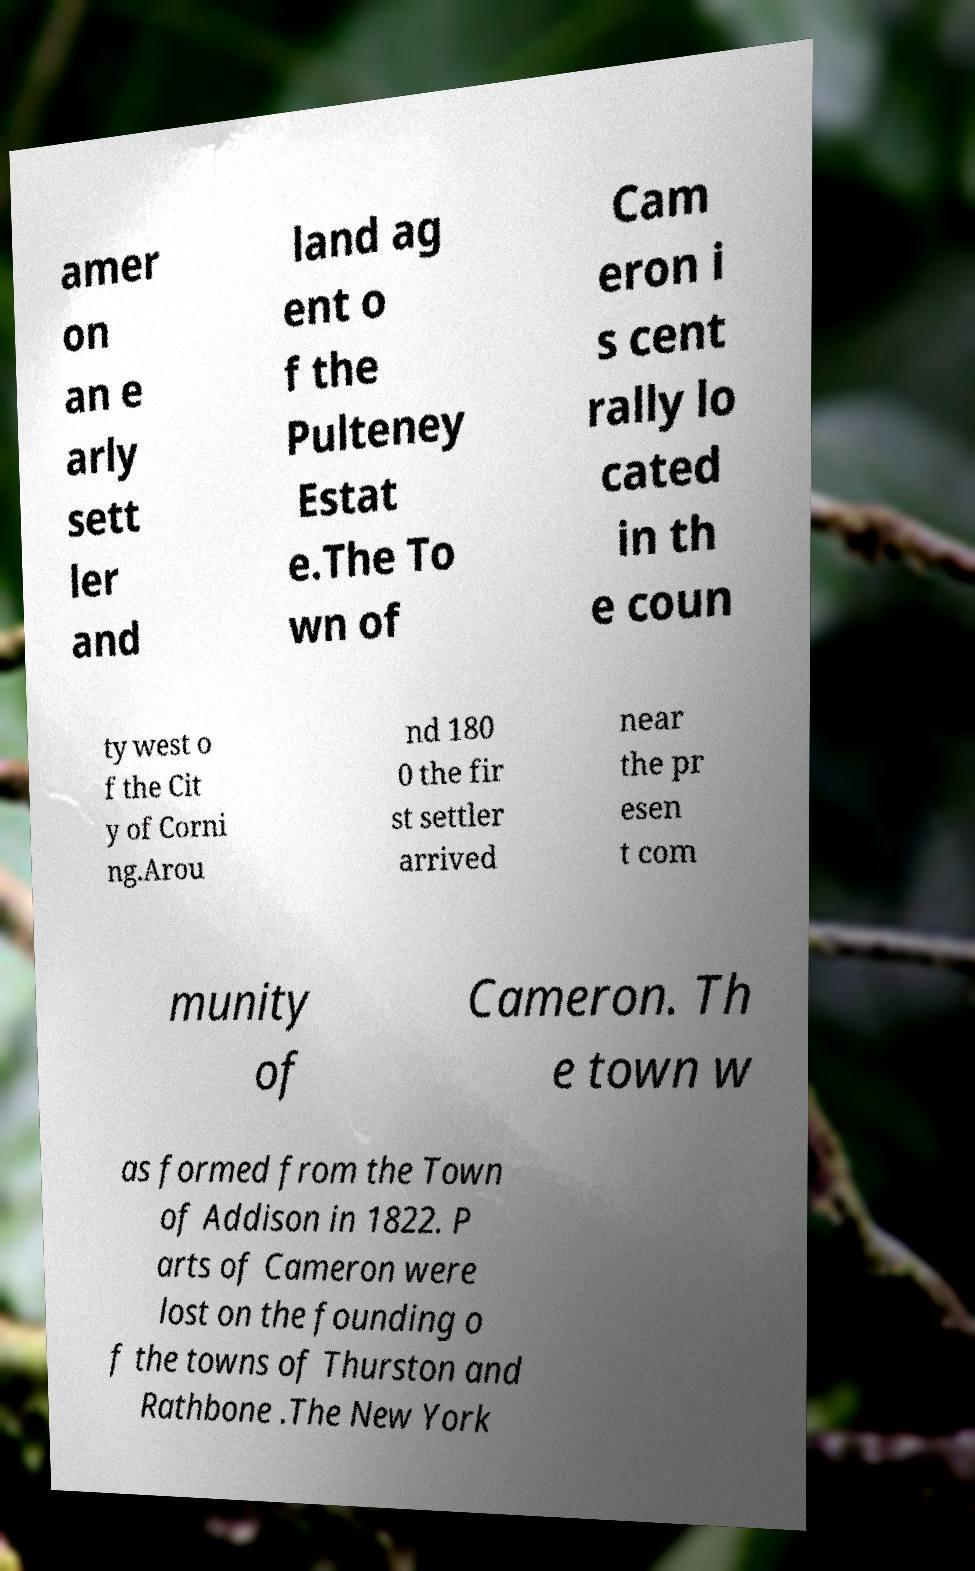Can you accurately transcribe the text from the provided image for me? amer on an e arly sett ler and land ag ent o f the Pulteney Estat e.The To wn of Cam eron i s cent rally lo cated in th e coun ty west o f the Cit y of Corni ng.Arou nd 180 0 the fir st settler arrived near the pr esen t com munity of Cameron. Th e town w as formed from the Town of Addison in 1822. P arts of Cameron were lost on the founding o f the towns of Thurston and Rathbone .The New York 